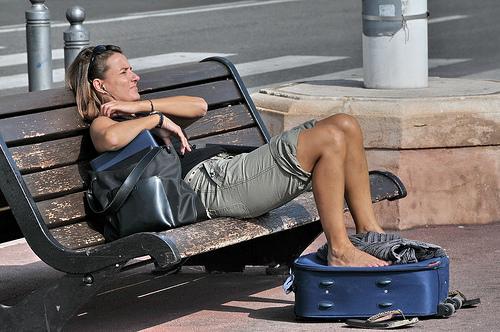What is the person sitting on?
Give a very brief answer. Bench. Does this lady look like is pregnant?
Give a very brief answer. No. Does this person look to be relaxing?
Keep it brief. Yes. What color is the purse?
Give a very brief answer. Black. 